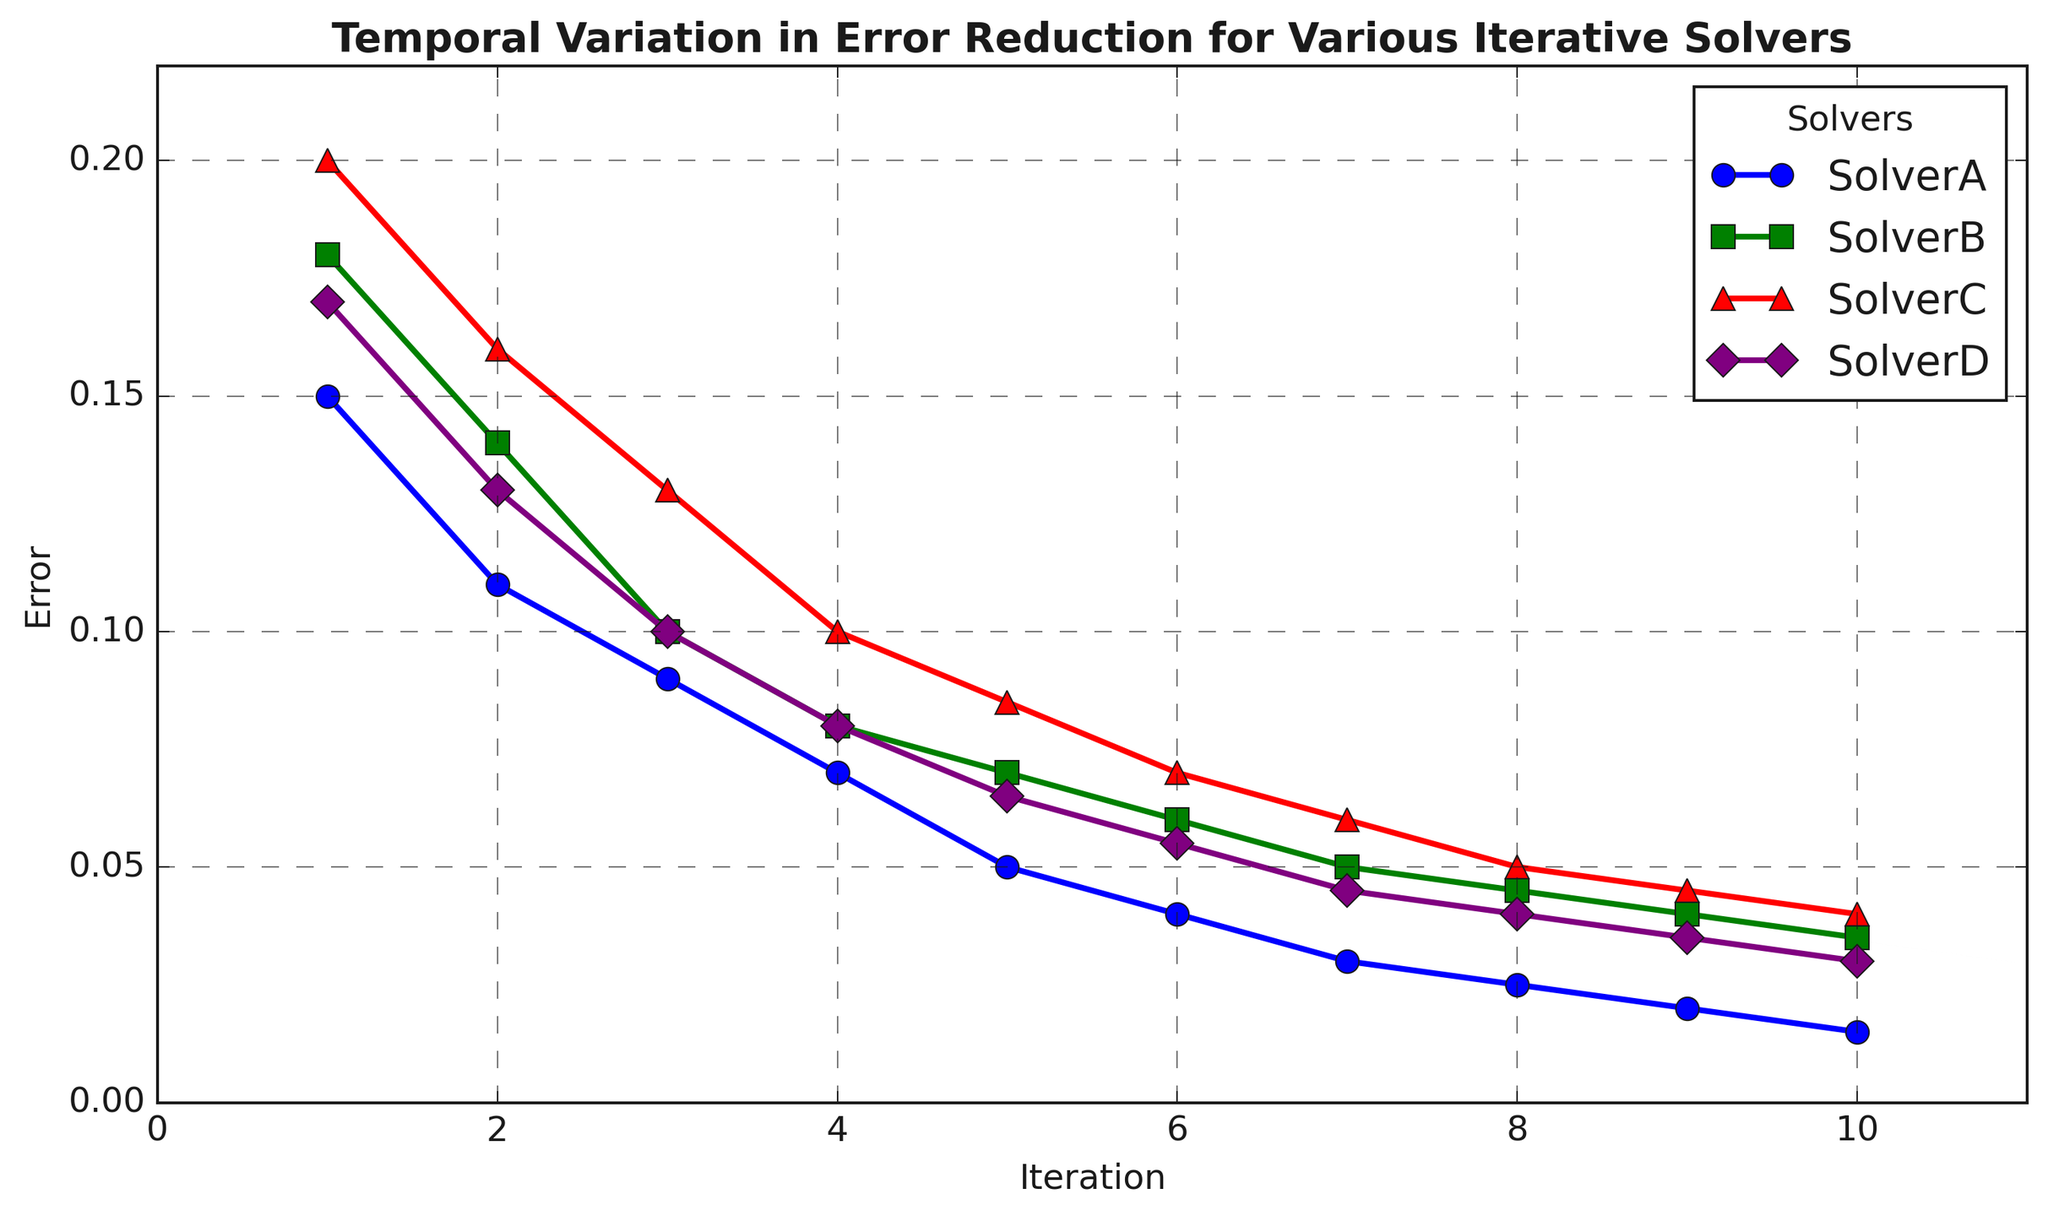What is the initial error value for Solver C? Locate the starting point of Solver C and find the error value at iteration 1 plotted with a specific marker and color. The initial error for Solver C at iteration 1 is 0.2.
Answer: 0.2 Which solver shows the steepest decline in error from iteration 1 to iteration 2? Compare the error reductions from iteration 1 to iteration 2 across all solvers. Solver B shows a reduction from 0.18 to 0.14, Solver C from 0.2 to 0.16, etc. The largest drop is for Solver C (0.2 - 0.16 = 0.04).
Answer: Solver C How does the error at iteration 5 for Solver A compare to Solver B? Look at the error values at iteration 5 for both Solver A and Solver B. Solver A has 0.05, and Solver B has 0.07, indicating Solver A's error is lower.
Answer: Solver A's error at iteration 5 is lower than Solver B's Which solver reaches an error of 0.03 first? Review the plotted lines for each solver to see when they first reach an error of 0.03 or lower. Solver A reaches this at iteration 7.
Answer: Solver A What is the average error reduction per iteration for Solver D from iteration 1 to iteration 10? Calculate the total error reduction for Solver D, which is 0.17 - 0.03 = 0.14, then divide it by the number of iterations (10 - 1 = 9). Average reduction = 0.14 / 9 ≈ 0.0156.
Answer: Approximately 0.0156 Between which iteration does Solver B experience the smallest decrease in error? Examine the intervals between iterations for Solver B and find the smallest error reduction between consecutive iterations. The error reductions are: 0.04, 0.04, 0.02, 0.01, 0.01, 0.01, 0.005, 0.005, 0.005. The smallest decrease happens between iterations 8 and 9, and 9 and 10 (both by 0.005).
Answer: Iterations 8 and 9 At iteration 6, which solver has the highest error rate? Compare the error rates at iteration 6 for all solvers. Solver A: 0.04, Solver B: 0.06, Solver C: 0.07, Solver D: 0.055. Solver C has the highest error rate.
Answer: Solver C If Solver A keeps reducing its error rate at the same pace as between iterations 1 and 10, what would its error be at iteration 15? The total reduction from iteration 1 to 10 for Solver A is 0.15 - 0.015 = 0.135 over 9 iterations, so the average reduction per iteration is 0.135 / 9 = 0.015. Projecting this pace to iteration 15 (additional 5 iterations): error at iteration 10 (0.015) - 5 * 0.015 = 0.015 - 0.075 = -0.06. Since error cannot be negative, it would likely approach 0.
Answer: Approximately 0 Which solvers reach an error lower than 0.05 by iteration 10? Determine the final error by iteration 10 for each solver. Solver A: 0.015, Solver B: 0.035, Solver C: 0.04, Solver D: 0.03. All solvers reach an error lower than 0.05.
Answer: All solvers What is the combined error at iteration 5 for all solvers? Sum the error values at iteration 5 for all solvers. Solver A: 0.05, Solver B: 0.07, Solver C: 0.085, Solver D: 0.065. Combined error = 0.05 + 0.07 + 0.085 + 0.065 = 0.27.
Answer: 0.27 